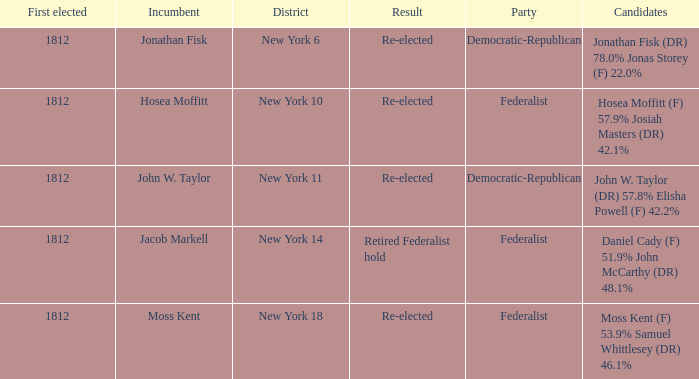Name the least first elected 1812.0. 